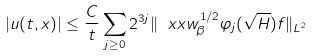Convert formula to latex. <formula><loc_0><loc_0><loc_500><loc_500>| u ( t , x ) | \leq \frac { C } { t } \sum _ { j \geq 0 } 2 ^ { 3 j } \| \ x x w _ { \beta } ^ { 1 / 2 } \varphi _ { j } ( \sqrt { H } ) f \| _ { L ^ { 2 } }</formula> 